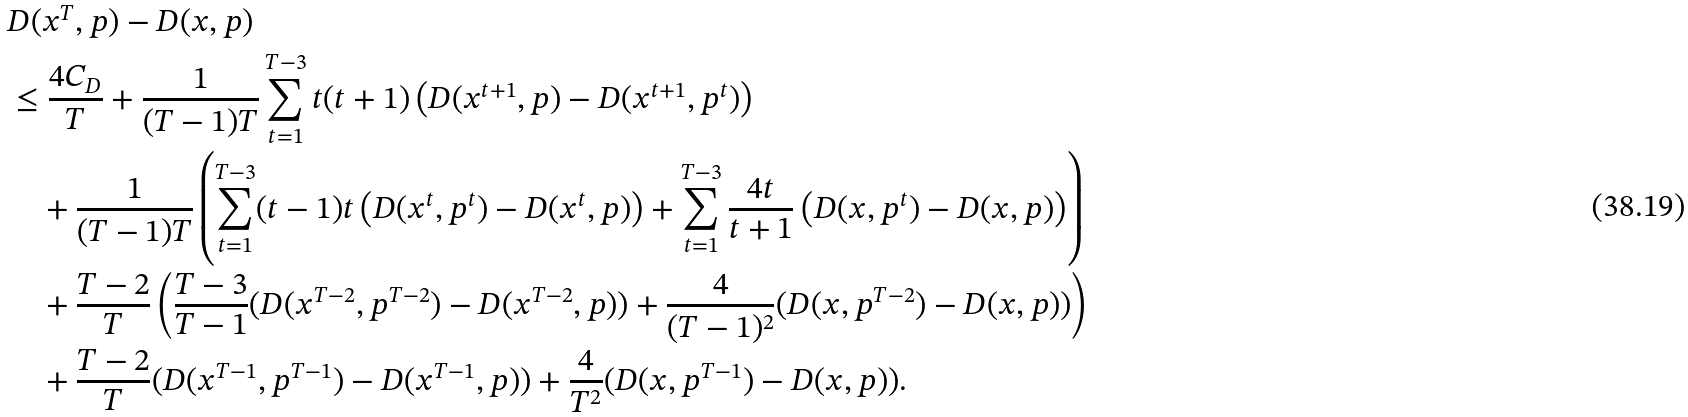<formula> <loc_0><loc_0><loc_500><loc_500>& D ( x ^ { T } , p ) - D ( x , p ) \\ & \leq \frac { 4 C _ { D } } { T } + \frac { 1 } { ( T - 1 ) T } \sum _ { t = 1 } ^ { T - 3 } t ( t + 1 ) \left ( D ( x ^ { t + 1 } , p ) - D ( x ^ { t + 1 } , p ^ { t } ) \right ) \\ & \quad + \frac { 1 } { ( T - 1 ) T } \left ( \sum _ { t = 1 } ^ { T - 3 } ( t - 1 ) t \left ( D ( x ^ { t } , p ^ { t } ) - D ( x ^ { t } , p ) \right ) + \sum _ { t = 1 } ^ { T - 3 } \frac { 4 t } { t + 1 } \left ( D ( x , p ^ { t } ) - D ( x , p ) \right ) \right ) \\ & \quad + \frac { T - 2 } { T } \left ( \frac { T - 3 } { T - 1 } ( D ( x ^ { T - 2 } , p ^ { T - 2 } ) - D ( x ^ { T - 2 } , p ) ) + \frac { 4 } { ( T - 1 ) ^ { 2 } } ( D ( x , p ^ { T - 2 } ) - D ( x , p ) ) \right ) \\ & \quad + \frac { T - 2 } { T } ( D ( x ^ { T - 1 } , p ^ { T - 1 } ) - D ( x ^ { T - 1 } , p ) ) + \frac { 4 } { T ^ { 2 } } ( D ( x , p ^ { T - 1 } ) - D ( x , p ) ) .</formula> 